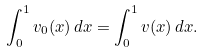<formula> <loc_0><loc_0><loc_500><loc_500>\int _ { 0 } ^ { 1 } v _ { 0 } ( x ) \, d x = \int _ { 0 } ^ { 1 } v ( x ) \, d x .</formula> 